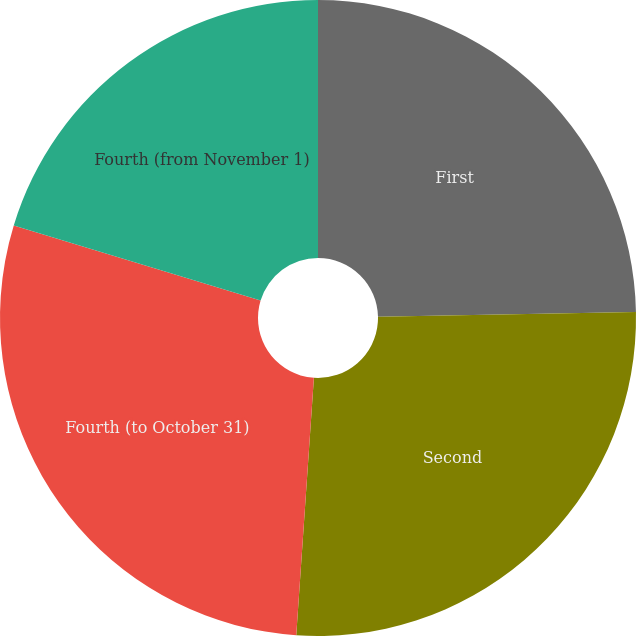Convert chart. <chart><loc_0><loc_0><loc_500><loc_500><pie_chart><fcel>First<fcel>Second<fcel>Fourth (to October 31)<fcel>Fourth (from November 1)<nl><fcel>24.7%<fcel>26.39%<fcel>28.61%<fcel>20.3%<nl></chart> 